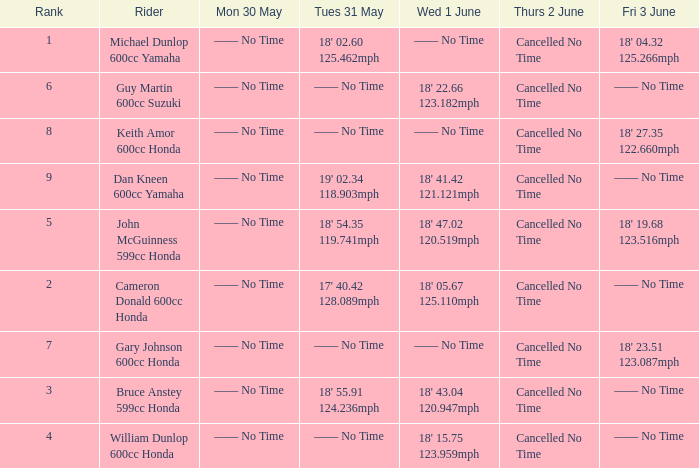What is the number of riders that had a Tues 31 May time of 18' 55.91 124.236mph? 1.0. 